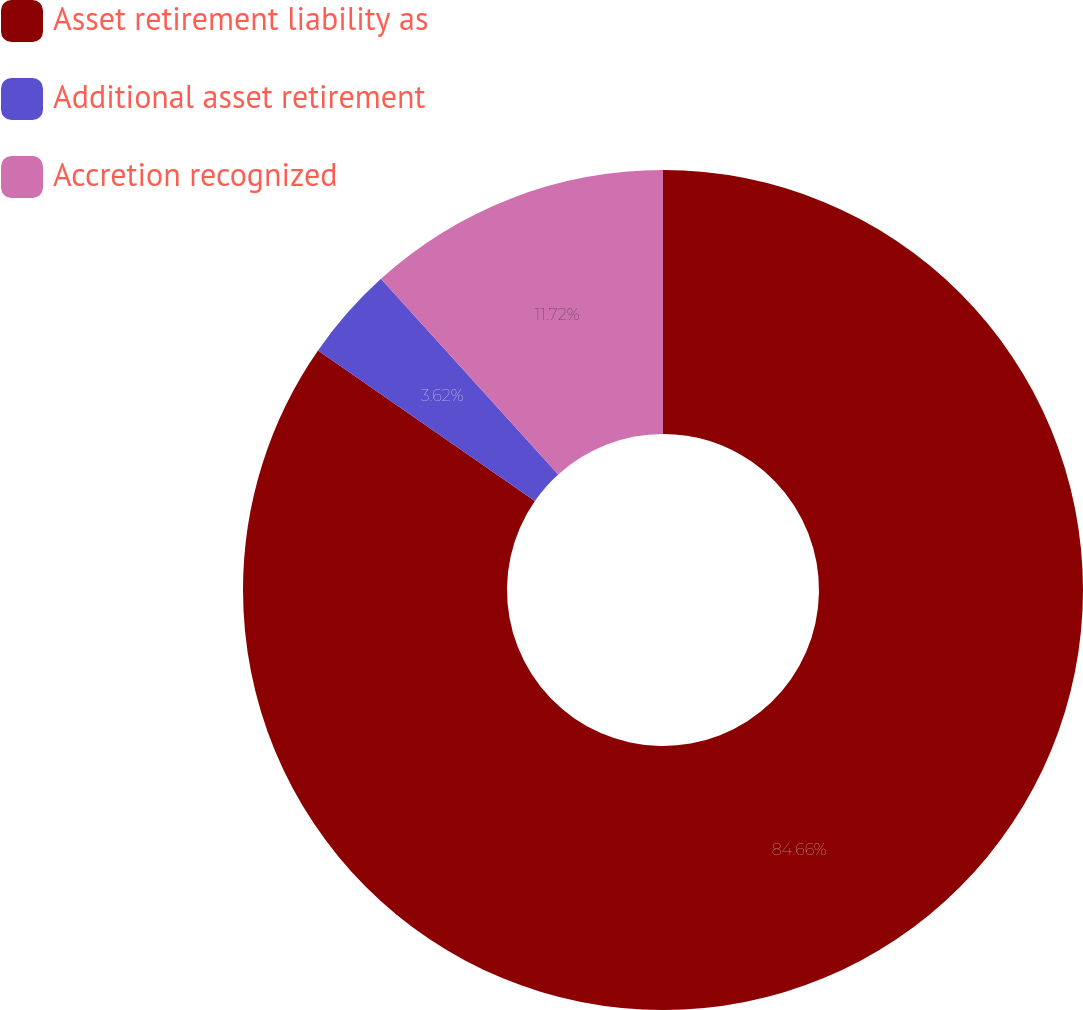Convert chart. <chart><loc_0><loc_0><loc_500><loc_500><pie_chart><fcel>Asset retirement liability as<fcel>Additional asset retirement<fcel>Accretion recognized<nl><fcel>84.66%<fcel>3.62%<fcel>11.72%<nl></chart> 